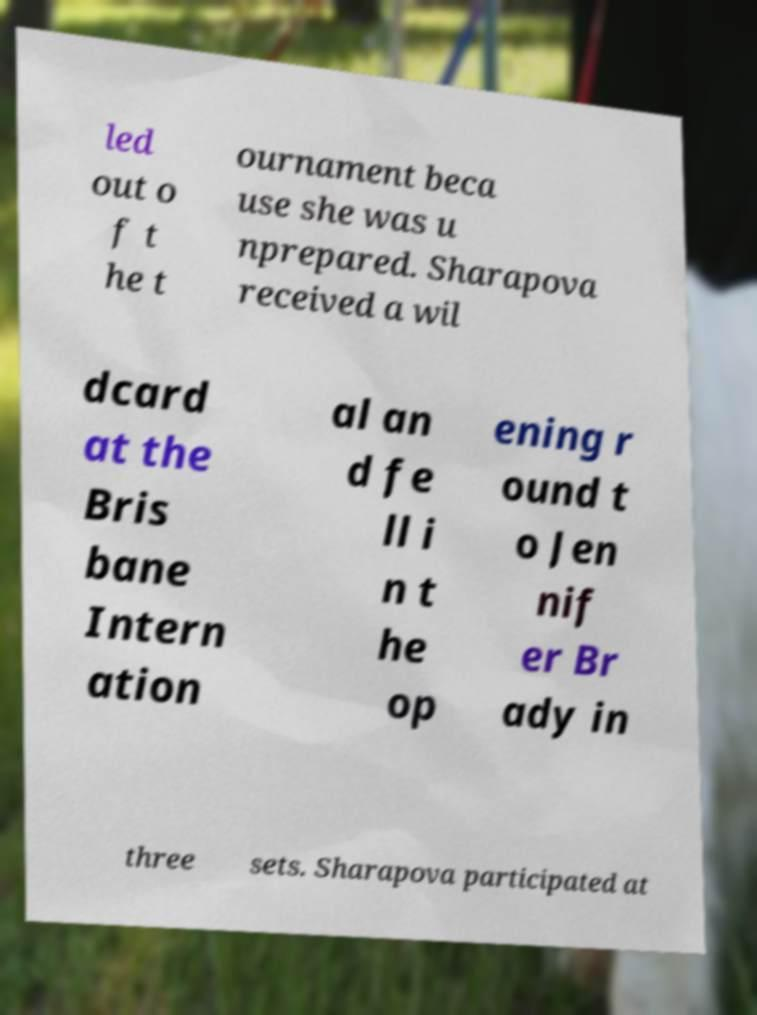Please read and relay the text visible in this image. What does it say? led out o f t he t ournament beca use she was u nprepared. Sharapova received a wil dcard at the Bris bane Intern ation al an d fe ll i n t he op ening r ound t o Jen nif er Br ady in three sets. Sharapova participated at 